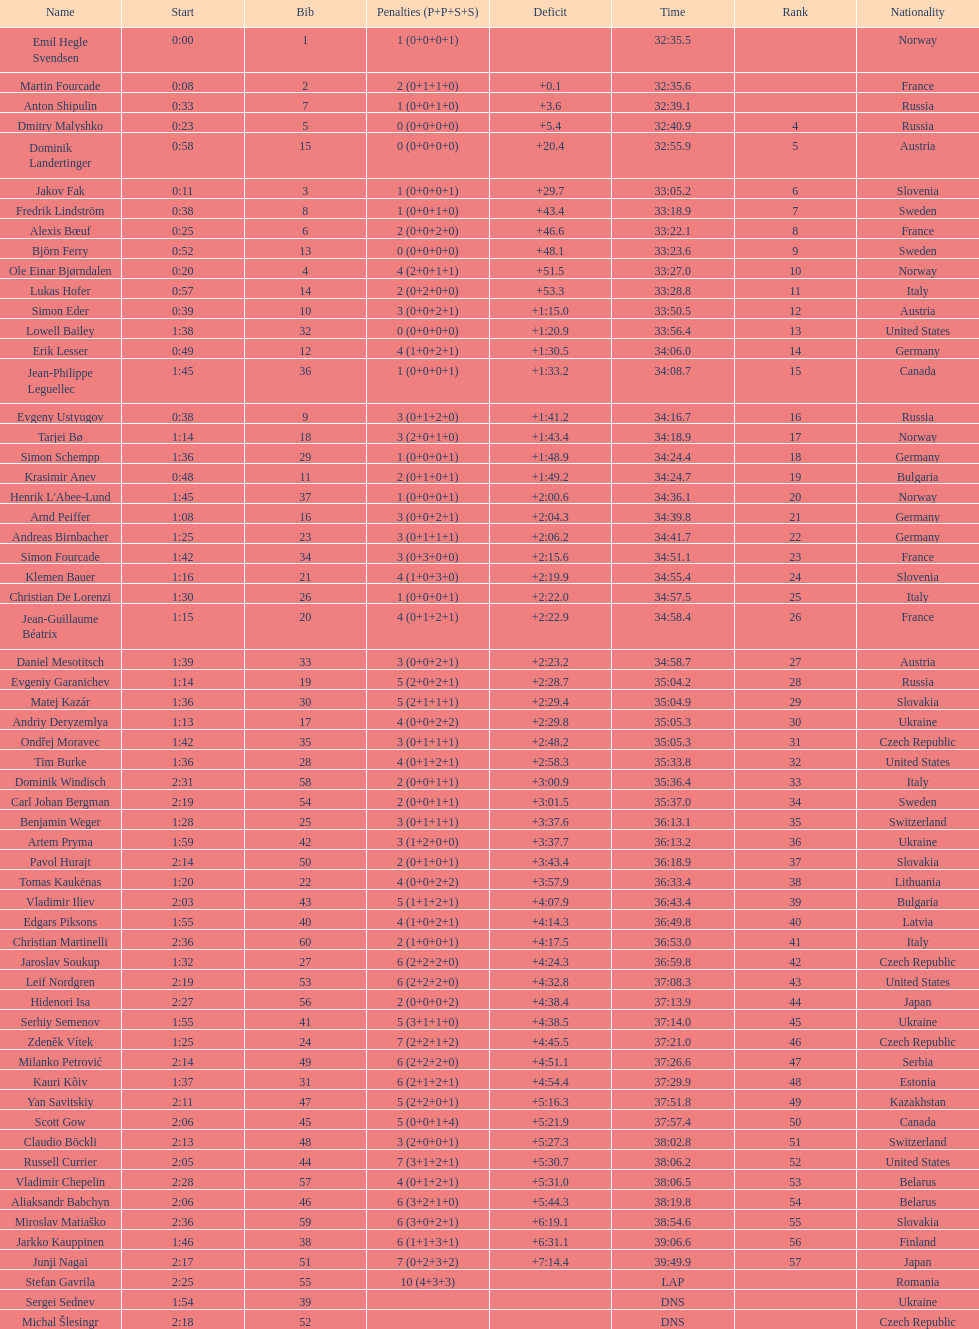How long did it take for erik lesser to finish? 34:06.0. Parse the table in full. {'header': ['Name', 'Start', 'Bib', 'Penalties (P+P+S+S)', 'Deficit', 'Time', 'Rank', 'Nationality'], 'rows': [['Emil Hegle Svendsen', '0:00', '1', '1 (0+0+0+1)', '', '32:35.5', '', 'Norway'], ['Martin Fourcade', '0:08', '2', '2 (0+1+1+0)', '+0.1', '32:35.6', '', 'France'], ['Anton Shipulin', '0:33', '7', '1 (0+0+1+0)', '+3.6', '32:39.1', '', 'Russia'], ['Dmitry Malyshko', '0:23', '5', '0 (0+0+0+0)', '+5.4', '32:40.9', '4', 'Russia'], ['Dominik Landertinger', '0:58', '15', '0 (0+0+0+0)', '+20.4', '32:55.9', '5', 'Austria'], ['Jakov Fak', '0:11', '3', '1 (0+0+0+1)', '+29.7', '33:05.2', '6', 'Slovenia'], ['Fredrik Lindström', '0:38', '8', '1 (0+0+1+0)', '+43.4', '33:18.9', '7', 'Sweden'], ['Alexis Bœuf', '0:25', '6', '2 (0+0+2+0)', '+46.6', '33:22.1', '8', 'France'], ['Björn Ferry', '0:52', '13', '0 (0+0+0+0)', '+48.1', '33:23.6', '9', 'Sweden'], ['Ole Einar Bjørndalen', '0:20', '4', '4 (2+0+1+1)', '+51.5', '33:27.0', '10', 'Norway'], ['Lukas Hofer', '0:57', '14', '2 (0+2+0+0)', '+53.3', '33:28.8', '11', 'Italy'], ['Simon Eder', '0:39', '10', '3 (0+0+2+1)', '+1:15.0', '33:50.5', '12', 'Austria'], ['Lowell Bailey', '1:38', '32', '0 (0+0+0+0)', '+1:20.9', '33:56.4', '13', 'United States'], ['Erik Lesser', '0:49', '12', '4 (1+0+2+1)', '+1:30.5', '34:06.0', '14', 'Germany'], ['Jean-Philippe Leguellec', '1:45', '36', '1 (0+0+0+1)', '+1:33.2', '34:08.7', '15', 'Canada'], ['Evgeny Ustyugov', '0:38', '9', '3 (0+1+2+0)', '+1:41.2', '34:16.7', '16', 'Russia'], ['Tarjei Bø', '1:14', '18', '3 (2+0+1+0)', '+1:43.4', '34:18.9', '17', 'Norway'], ['Simon Schempp', '1:36', '29', '1 (0+0+0+1)', '+1:48.9', '34:24.4', '18', 'Germany'], ['Krasimir Anev', '0:48', '11', '2 (0+1+0+1)', '+1:49.2', '34:24.7', '19', 'Bulgaria'], ["Henrik L'Abee-Lund", '1:45', '37', '1 (0+0+0+1)', '+2:00.6', '34:36.1', '20', 'Norway'], ['Arnd Peiffer', '1:08', '16', '3 (0+0+2+1)', '+2:04.3', '34:39.8', '21', 'Germany'], ['Andreas Birnbacher', '1:25', '23', '3 (0+1+1+1)', '+2:06.2', '34:41.7', '22', 'Germany'], ['Simon Fourcade', '1:42', '34', '3 (0+3+0+0)', '+2:15.6', '34:51.1', '23', 'France'], ['Klemen Bauer', '1:16', '21', '4 (1+0+3+0)', '+2:19.9', '34:55.4', '24', 'Slovenia'], ['Christian De Lorenzi', '1:30', '26', '1 (0+0+0+1)', '+2:22.0', '34:57.5', '25', 'Italy'], ['Jean-Guillaume Béatrix', '1:15', '20', '4 (0+1+2+1)', '+2:22.9', '34:58.4', '26', 'France'], ['Daniel Mesotitsch', '1:39', '33', '3 (0+0+2+1)', '+2:23.2', '34:58.7', '27', 'Austria'], ['Evgeniy Garanichev', '1:14', '19', '5 (2+0+2+1)', '+2:28.7', '35:04.2', '28', 'Russia'], ['Matej Kazár', '1:36', '30', '5 (2+1+1+1)', '+2:29.4', '35:04.9', '29', 'Slovakia'], ['Andriy Deryzemlya', '1:13', '17', '4 (0+0+2+2)', '+2:29.8', '35:05.3', '30', 'Ukraine'], ['Ondřej Moravec', '1:42', '35', '3 (0+1+1+1)', '+2:48.2', '35:05.3', '31', 'Czech Republic'], ['Tim Burke', '1:36', '28', '4 (0+1+2+1)', '+2:58.3', '35:33.8', '32', 'United States'], ['Dominik Windisch', '2:31', '58', '2 (0+0+1+1)', '+3:00.9', '35:36.4', '33', 'Italy'], ['Carl Johan Bergman', '2:19', '54', '2 (0+0+1+1)', '+3:01.5', '35:37.0', '34', 'Sweden'], ['Benjamin Weger', '1:28', '25', '3 (0+1+1+1)', '+3:37.6', '36:13.1', '35', 'Switzerland'], ['Artem Pryma', '1:59', '42', '3 (1+2+0+0)', '+3:37.7', '36:13.2', '36', 'Ukraine'], ['Pavol Hurajt', '2:14', '50', '2 (0+1+0+1)', '+3:43.4', '36:18.9', '37', 'Slovakia'], ['Tomas Kaukėnas', '1:20', '22', '4 (0+0+2+2)', '+3:57.9', '36:33.4', '38', 'Lithuania'], ['Vladimir Iliev', '2:03', '43', '5 (1+1+2+1)', '+4:07.9', '36:43.4', '39', 'Bulgaria'], ['Edgars Piksons', '1:55', '40', '4 (1+0+2+1)', '+4:14.3', '36:49.8', '40', 'Latvia'], ['Christian Martinelli', '2:36', '60', '2 (1+0+0+1)', '+4:17.5', '36:53.0', '41', 'Italy'], ['Jaroslav Soukup', '1:32', '27', '6 (2+2+2+0)', '+4:24.3', '36:59.8', '42', 'Czech Republic'], ['Leif Nordgren', '2:19', '53', '6 (2+2+2+0)', '+4:32.8', '37:08.3', '43', 'United States'], ['Hidenori Isa', '2:27', '56', '2 (0+0+0+2)', '+4:38.4', '37:13.9', '44', 'Japan'], ['Serhiy Semenov', '1:55', '41', '5 (3+1+1+0)', '+4:38.5', '37:14.0', '45', 'Ukraine'], ['Zdeněk Vítek', '1:25', '24', '7 (2+2+1+2)', '+4:45.5', '37:21.0', '46', 'Czech Republic'], ['Milanko Petrović', '2:14', '49', '6 (2+2+2+0)', '+4:51.1', '37:26.6', '47', 'Serbia'], ['Kauri Kõiv', '1:37', '31', '6 (2+1+2+1)', '+4:54.4', '37:29.9', '48', 'Estonia'], ['Yan Savitskiy', '2:11', '47', '5 (2+2+0+1)', '+5:16.3', '37:51.8', '49', 'Kazakhstan'], ['Scott Gow', '2:06', '45', '5 (0+0+1+4)', '+5:21.9', '37:57.4', '50', 'Canada'], ['Claudio Böckli', '2:13', '48', '3 (2+0+0+1)', '+5:27.3', '38:02.8', '51', 'Switzerland'], ['Russell Currier', '2:05', '44', '7 (3+1+2+1)', '+5:30.7', '38:06.2', '52', 'United States'], ['Vladimir Chepelin', '2:28', '57', '4 (0+1+2+1)', '+5:31.0', '38:06.5', '53', 'Belarus'], ['Aliaksandr Babchyn', '2:06', '46', '6 (3+2+1+0)', '+5:44.3', '38:19.8', '54', 'Belarus'], ['Miroslav Matiaško', '2:36', '59', '6 (3+0+2+1)', '+6:19.1', '38:54.6', '55', 'Slovakia'], ['Jarkko Kauppinen', '1:46', '38', '6 (1+1+3+1)', '+6:31.1', '39:06.6', '56', 'Finland'], ['Junji Nagai', '2:17', '51', '7 (0+2+3+2)', '+7:14.4', '39:49.9', '57', 'Japan'], ['Stefan Gavrila', '2:25', '55', '10 (4+3+3)', '', 'LAP', '', 'Romania'], ['Sergei Sednev', '1:54', '39', '', '', 'DNS', '', 'Ukraine'], ['Michal Šlesingr', '2:18', '52', '', '', 'DNS', '', 'Czech Republic']]} 